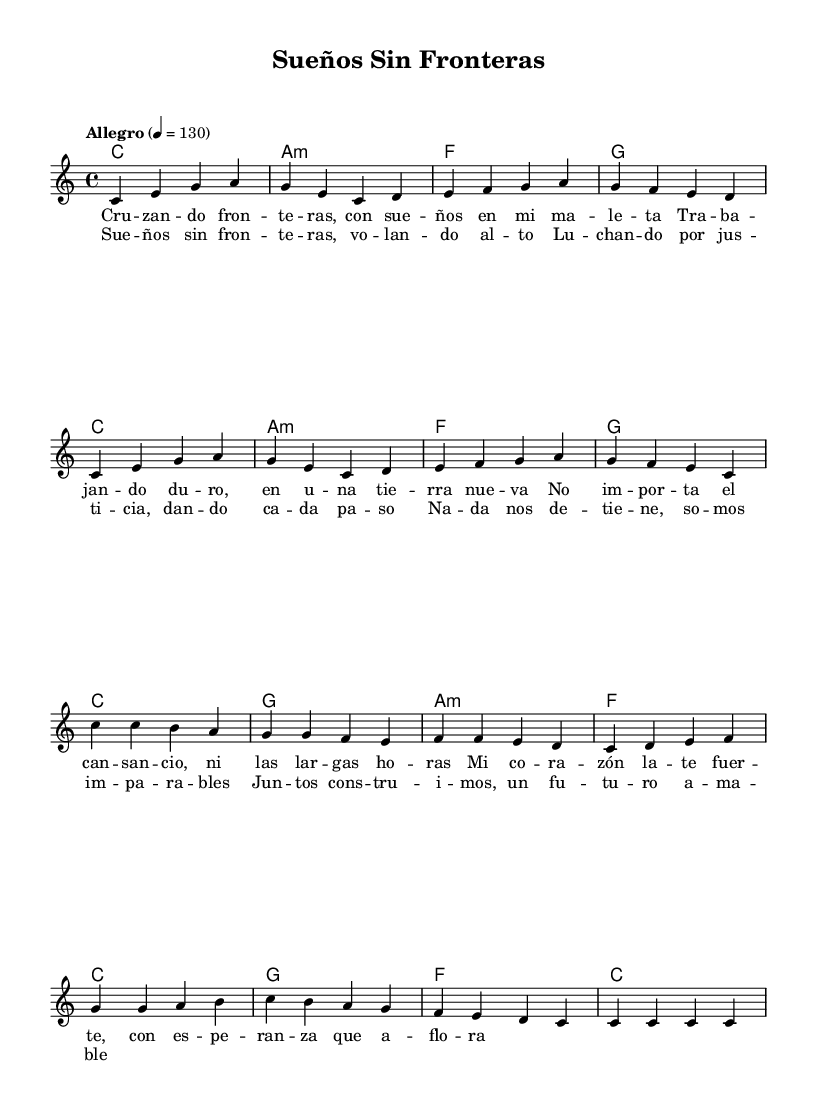What is the key signature of this music? The key signature is indicated at the beginning of the score, and it shows that there are no sharps or flats, meaning it is in C major.
Answer: C major What is the time signature of this music? The time signature is written next to the key signature, which indicates the number of beats per measure and the type of note that gets one beat. Here, it is 4/4, meaning four beats per measure.
Answer: 4/4 What is the tempo marking? The tempo marking is indicated at the beginning of the score, stating "Allegro," which is a term used to describe a fast tempo. The exact metronome marking is also provided as "4 = 130", specifying the speed at which the music should be played.
Answer: Allegro, 130 How many measures are in the verse? By counting the measures in the melody section labeled as "Verse," we see there are 8 measures indicated by the vertical lines separating them.
Answer: 8 measures What chord follows the key C major at the beginning of the verse? The chord progression starts with C major, followed by A minor, F major, and G major. The first chord after C major is A minor.
Answer: A minor What is the main theme of the lyrics? The lyrics express themes of perseverance and hope, focusing on overcoming challenges and pursuing dreams without borders. This message is consistent throughout the song.
Answer: Overcoming challenges and pursuing dreams Which part of the music has the most repeating notes? Upon examining the chorus, it contains a repetition of notes on the word "c", which is repeated multiple times within the musical structure of that section.
Answer: The chorus 